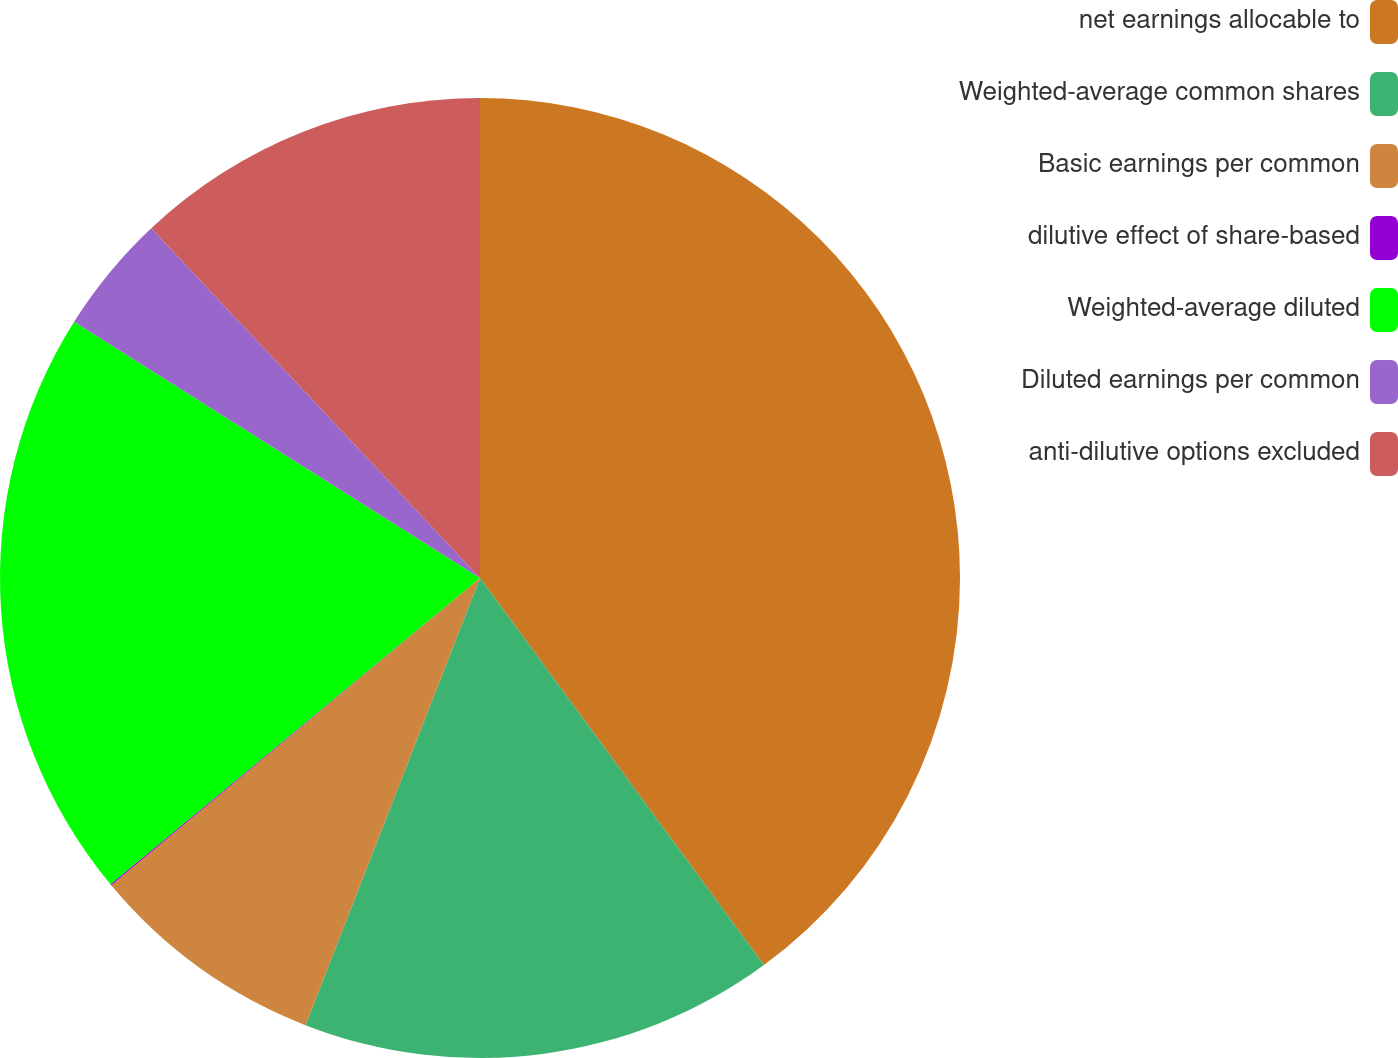Convert chart to OTSL. <chart><loc_0><loc_0><loc_500><loc_500><pie_chart><fcel>net earnings allocable to<fcel>Weighted-average common shares<fcel>Basic earnings per common<fcel>dilutive effect of share-based<fcel>Weighted-average diluted<fcel>Diluted earnings per common<fcel>anti-dilutive options excluded<nl><fcel>39.93%<fcel>16.0%<fcel>8.02%<fcel>0.04%<fcel>19.98%<fcel>4.03%<fcel>12.01%<nl></chart> 